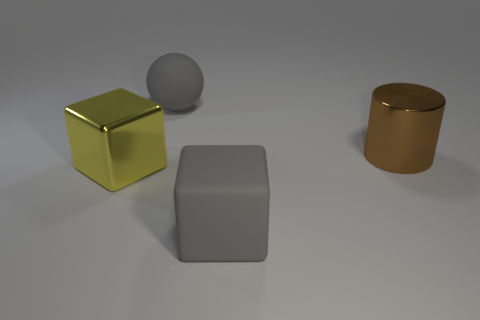Is the material of the big gray cube that is in front of the metallic cylinder the same as the gray object behind the big yellow metal thing?
Offer a terse response. Yes. How big is the gray thing that is in front of the big gray object behind the large yellow shiny block that is to the left of the shiny cylinder?
Your response must be concise. Large. How many cylinders are the same material as the brown object?
Offer a terse response. 0. Is the number of tiny gray metallic blocks less than the number of big balls?
Provide a short and direct response. Yes. What size is the rubber thing that is the same shape as the large yellow metal object?
Provide a short and direct response. Large. Does the block to the right of the rubber sphere have the same material as the brown object?
Make the answer very short. No. Is the brown object the same shape as the large yellow object?
Offer a terse response. No. How many things are big gray matte things right of the large gray sphere or purple spheres?
Ensure brevity in your answer.  1. What is the size of the cylinder that is made of the same material as the big yellow cube?
Your response must be concise. Large. How many metallic cylinders have the same color as the big metal block?
Offer a very short reply. 0. 